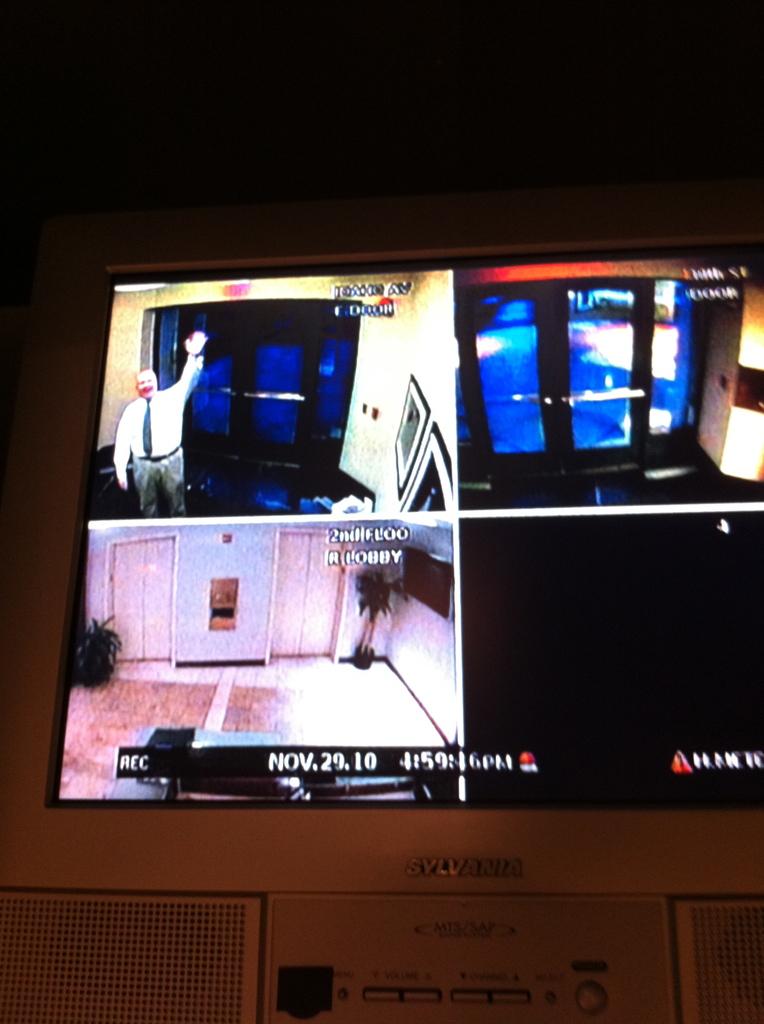What text is shown other than the date?
Your answer should be very brief. Time. What is the date on the monitor?
Provide a succinct answer. Nov.29.10. 